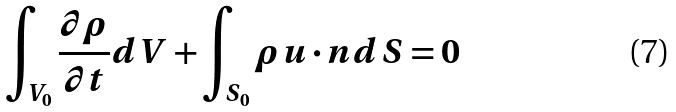<formula> <loc_0><loc_0><loc_500><loc_500>\int _ { V _ { 0 } } \frac { \partial \rho } { \partial t } d V + \int _ { S _ { 0 } } \rho u \cdot n d S = 0</formula> 